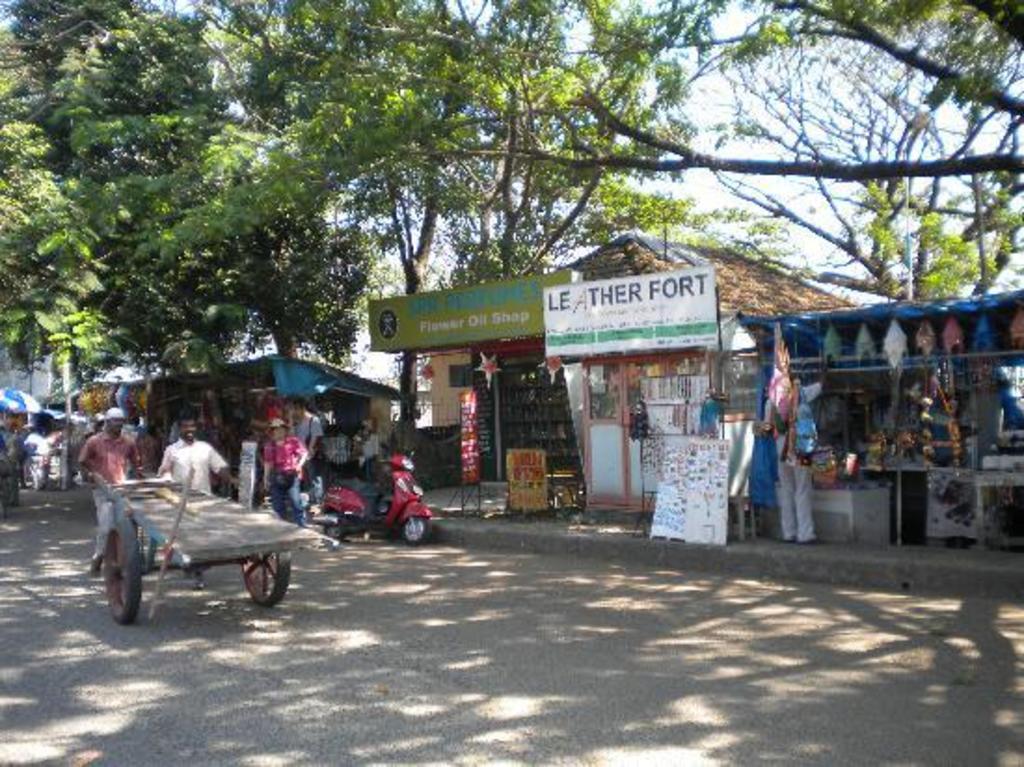In one or two sentences, can you explain what this image depicts? In this picture I can see there are two people pushing the trolley and there is a person standing beside the two wheeler and there is a buildings at the right side walkway and there are stores at right side. There are trees at left and the sky is clear. 